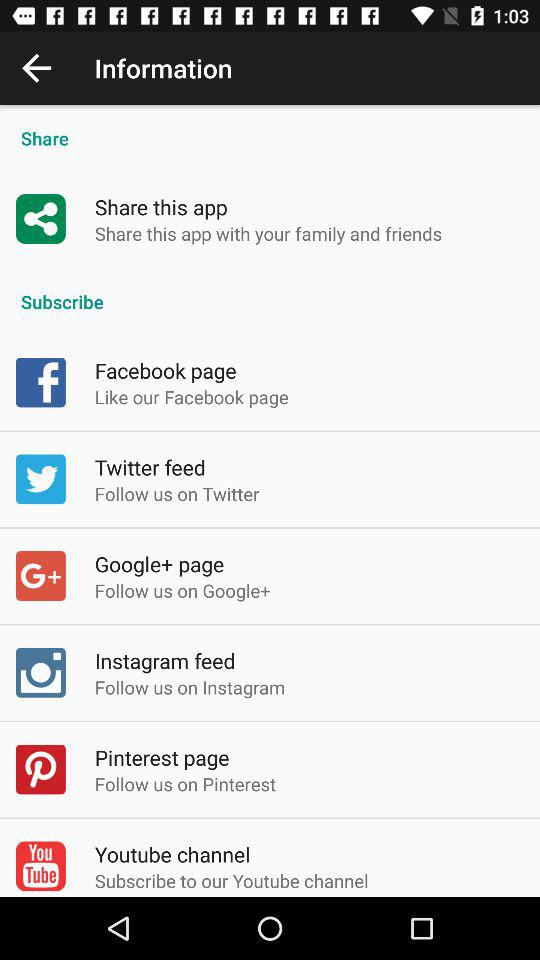What are the different options available to subscribe? The option is "Youtube channel". 